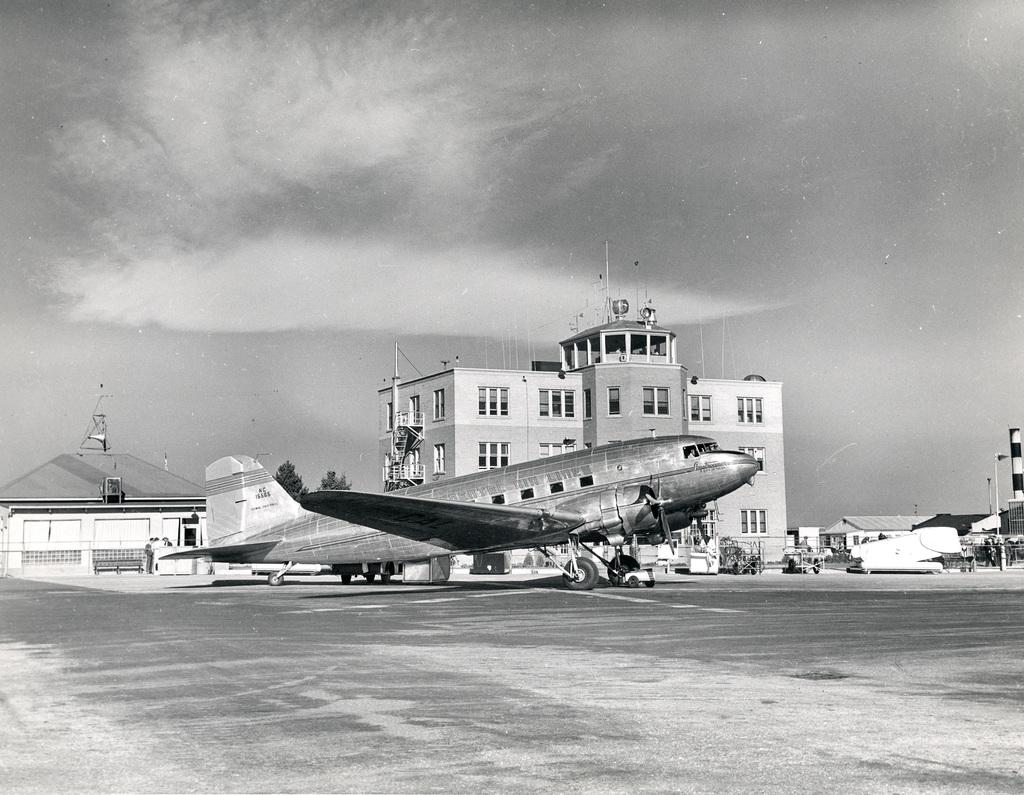What is the main subject of the image? The main subject of the image is an airplane. Where is the airplane located in the image? The airplane is at the center of the image. What can be seen in the background of the image? There are buildings and trees in the background of the image. What is visible at the top of the image? The sky is visible at the top of the image. What type of company is depicted on the airplane's tail in the image? There is no company logo or name visible on the airplane's tail in the image. How many pins are attached to the airplane's wings in the image? There are no pins present on the airplane's wings in the image. 